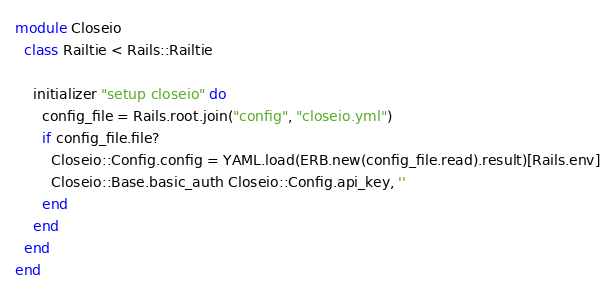Convert code to text. <code><loc_0><loc_0><loc_500><loc_500><_Ruby_>module Closeio
  class Railtie < Rails::Railtie

    initializer "setup closeio" do
      config_file = Rails.root.join("config", "closeio.yml")
      if config_file.file?
        Closeio::Config.config = YAML.load(ERB.new(config_file.read).result)[Rails.env]
        Closeio::Base.basic_auth Closeio::Config.api_key, ''
      end
    end
  end
end
</code> 